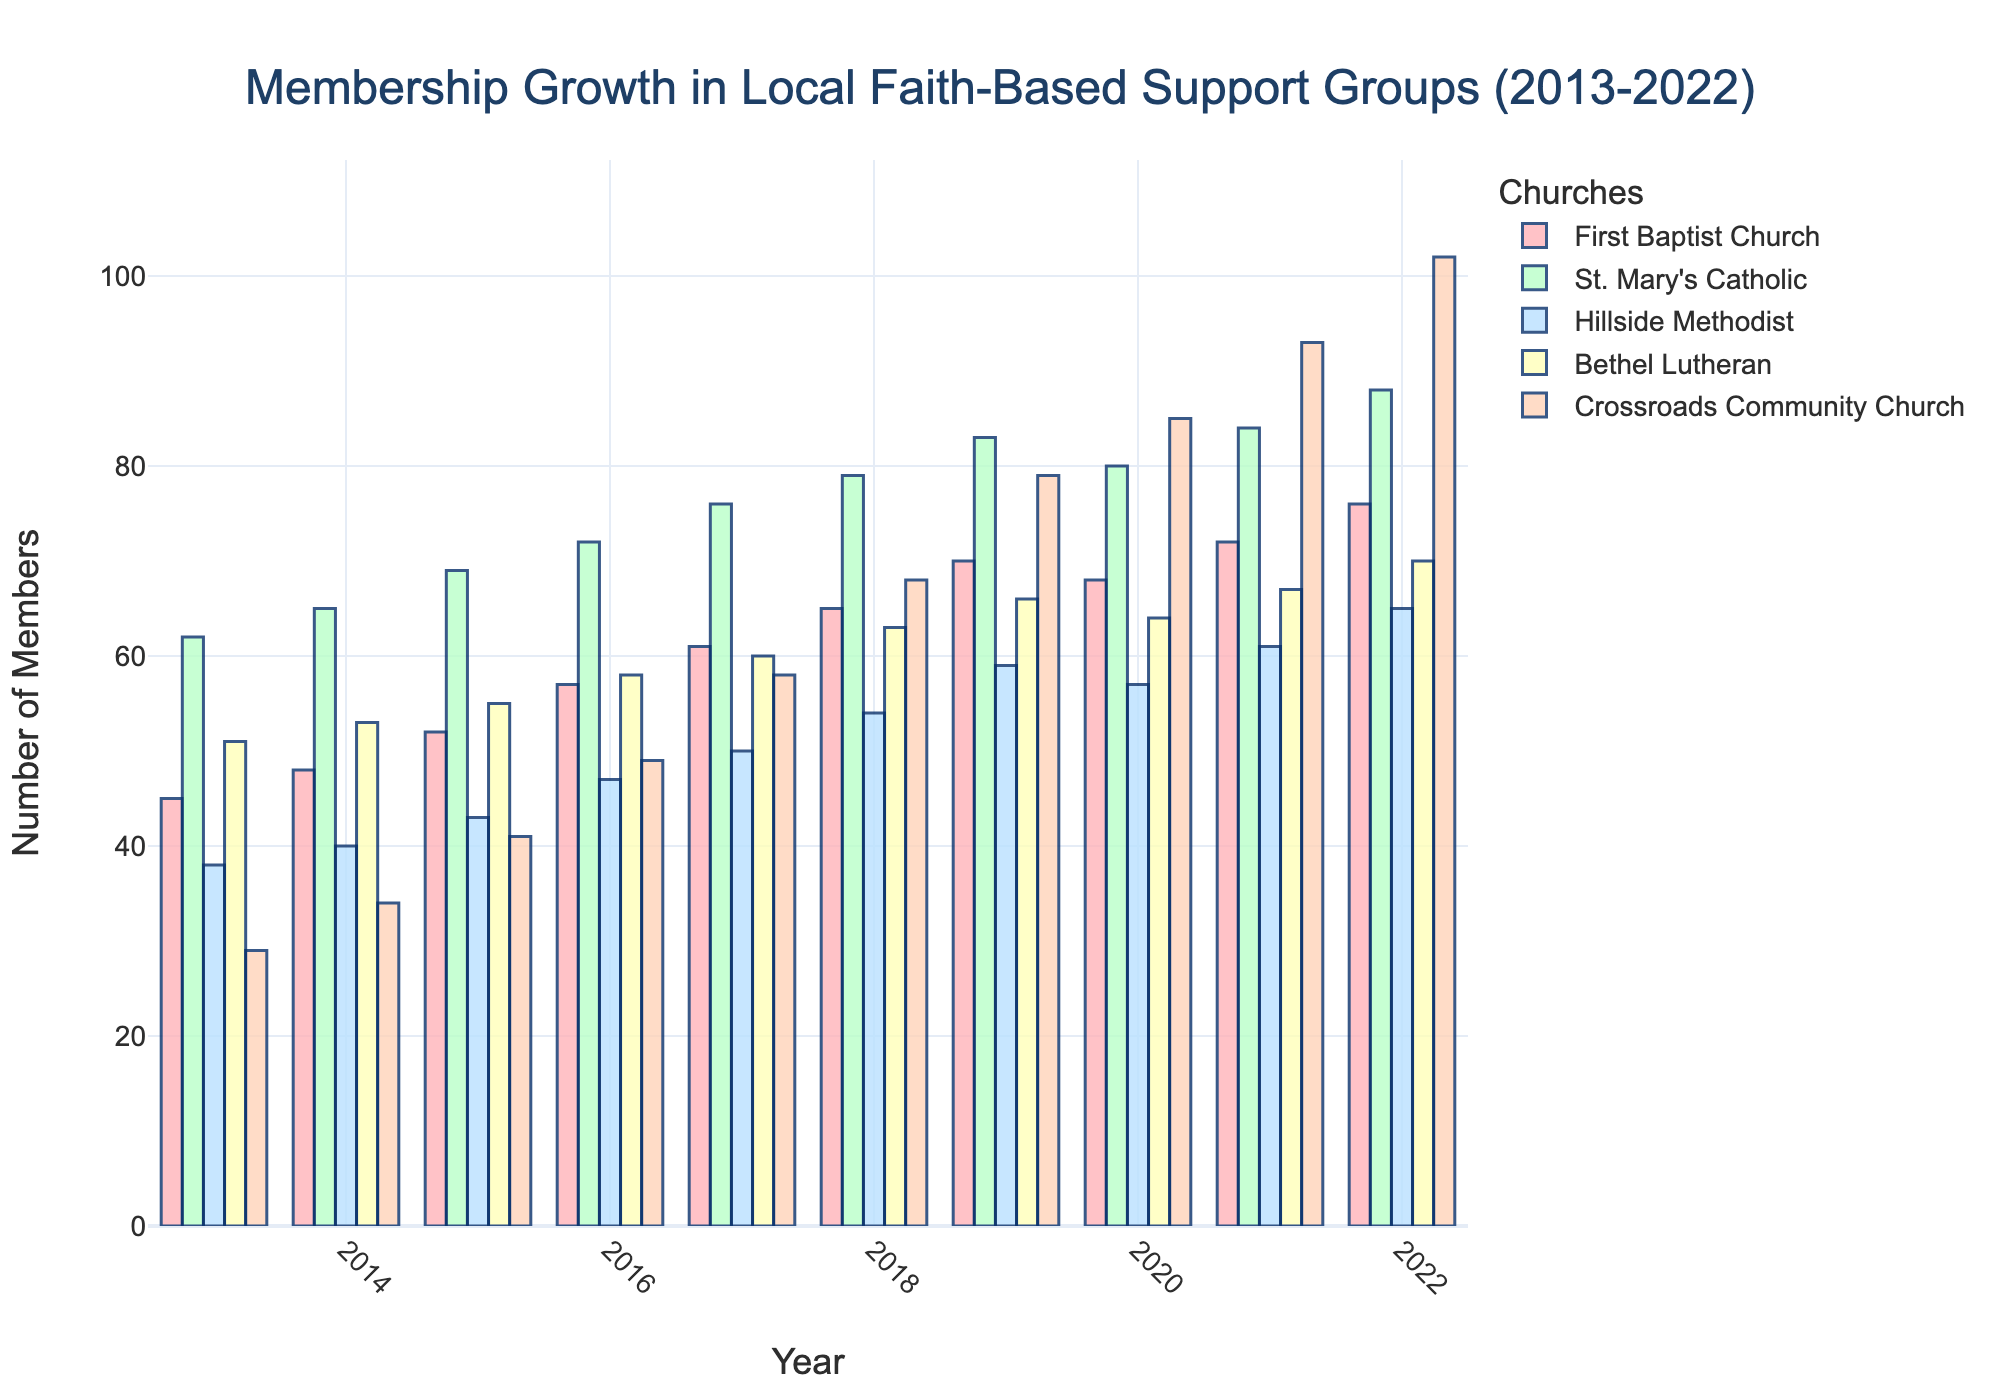what's the total increase in membership for Crossroads Community Church from 2013 to 2022? The membership for Crossroads Community Church in 2013 was 29, and in 2022 it was 102. Therefore, the increase is 102 - 29.
Answer: 73 which church has the highest number of members in 2022? In 2022, the membership numbers for all churches are represented by the heights of the bars. Crossroads Community Church has the highest bar in 2022, indicating the highest number of members.
Answer: Crossroads Community Church did any church have a decrease in membership from 2019 to 2020? By comparing the heights of the bars for each church between 2019 and 2020, we see that First Baptist Church decreased from 70 to 68 members.
Answer: First Baptist Church which year did St. Mary's Catholic Church surpass 80 members? Observing the heights of the bars for St. Mary's Catholic Church, it surpassed 80 members in 2019.
Answer: 2019 what is the average membership of Bethel Lutheran Church from 2013 to 2022? To calculate the average, sum all membership numbers for Bethel Lutheran Church from 2013 to 2022 and divide by the number of years: (51 + 53 + 55 + 58 + 60 + 63 + 66 + 64 + 67 + 70) / 10. The result is (607 / 10).
Answer: 60.7 how does the growth rate of Hillside Methodist compare between 2013-2017 and 2018-2022? Calculate the growth rate for each period first. From 2013 to 2017: 50 - 38 = 12. From 2018 to 2022: 65 - 54 = 11. Comparing the two periods, the growth was 12 in the first period and 11 in the second period.
Answer: Slightly higher growth rate in 2013-2017 which church had the steadiest growth throughout the decade? By observing the bars for each church, Bethel Lutheran Church shows a consistent increase in membership each year without any decline or significant fluctuation.
Answer: Bethel Lutheran Church what's the combined membership of First Baptist Church and Bethel Lutheran Church by 2022? In 2022, First Baptist Church had 76 members and Bethel Lutheran Church had 70. The combined membership is 76 + 70.
Answer: 146 how many churches had more than 50 members in 2020? In 2020, by observing the heights of the bars, First Baptist Church, St. Mary's Catholic, Hillside Methodist, Bethel Lutheran, and Crossroads Community Church all had more than 50 members.
Answer: 5 in which year did Hillside Methodist Church first exceed 50 members? Hillside Methodist Church first exceeded 50 members in 2017, where the bar height crosses the 50 mark.
Answer: 2017 